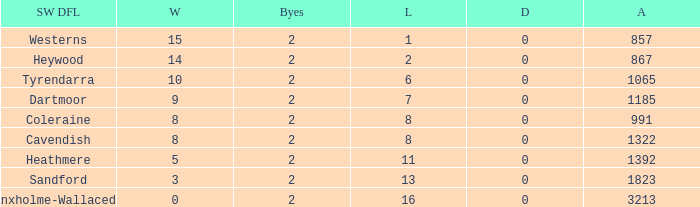How many Draws have a South West DFL of tyrendarra, and less than 10 wins? None. 